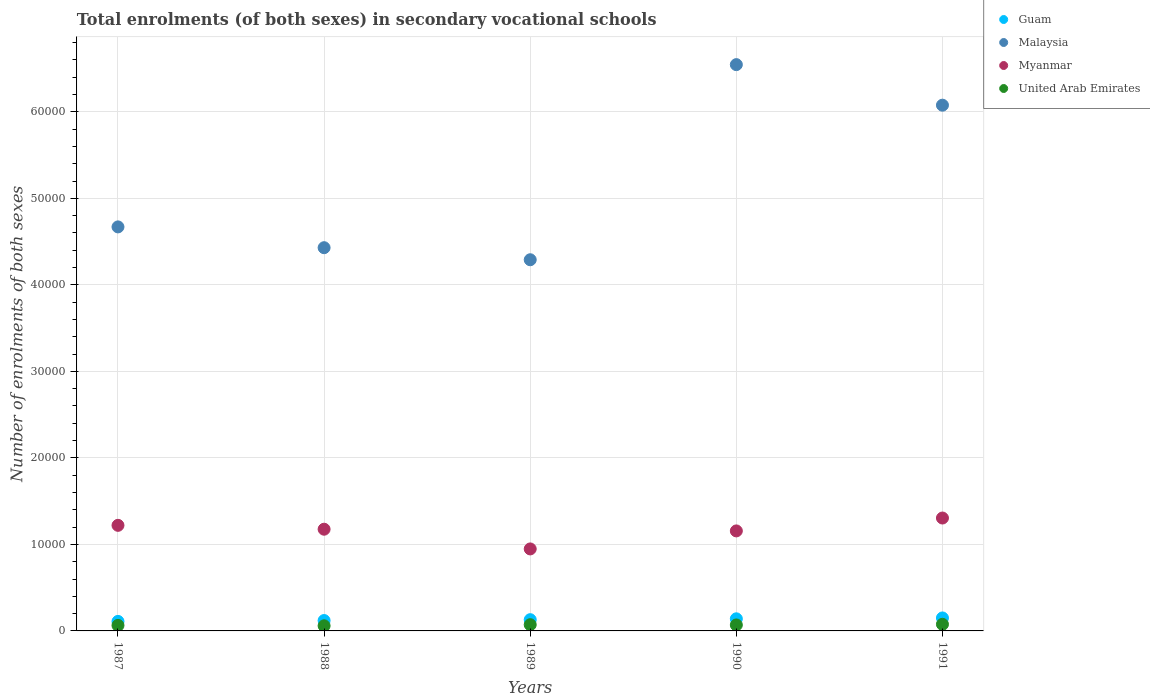How many different coloured dotlines are there?
Offer a terse response. 4. Is the number of dotlines equal to the number of legend labels?
Offer a terse response. Yes. What is the number of enrolments in secondary schools in United Arab Emirates in 1988?
Your answer should be compact. 591. Across all years, what is the maximum number of enrolments in secondary schools in Myanmar?
Keep it short and to the point. 1.30e+04. Across all years, what is the minimum number of enrolments in secondary schools in Malaysia?
Your answer should be very brief. 4.29e+04. In which year was the number of enrolments in secondary schools in Guam maximum?
Give a very brief answer. 1991. In which year was the number of enrolments in secondary schools in Myanmar minimum?
Make the answer very short. 1989. What is the total number of enrolments in secondary schools in Malaysia in the graph?
Provide a short and direct response. 2.60e+05. What is the difference between the number of enrolments in secondary schools in United Arab Emirates in 1987 and that in 1988?
Make the answer very short. 47. What is the difference between the number of enrolments in secondary schools in Malaysia in 1988 and the number of enrolments in secondary schools in Guam in 1987?
Offer a very short reply. 4.32e+04. What is the average number of enrolments in secondary schools in Myanmar per year?
Your response must be concise. 1.16e+04. In the year 1990, what is the difference between the number of enrolments in secondary schools in United Arab Emirates and number of enrolments in secondary schools in Myanmar?
Provide a short and direct response. -1.09e+04. In how many years, is the number of enrolments in secondary schools in United Arab Emirates greater than 38000?
Your answer should be compact. 0. What is the ratio of the number of enrolments in secondary schools in Guam in 1988 to that in 1990?
Your answer should be compact. 0.86. Is the number of enrolments in secondary schools in Guam in 1987 less than that in 1988?
Offer a very short reply. Yes. Is the difference between the number of enrolments in secondary schools in United Arab Emirates in 1987 and 1991 greater than the difference between the number of enrolments in secondary schools in Myanmar in 1987 and 1991?
Provide a succinct answer. Yes. What is the difference between the highest and the second highest number of enrolments in secondary schools in Malaysia?
Ensure brevity in your answer.  4687. What is the difference between the highest and the lowest number of enrolments in secondary schools in United Arab Emirates?
Your answer should be compact. 175. In how many years, is the number of enrolments in secondary schools in Malaysia greater than the average number of enrolments in secondary schools in Malaysia taken over all years?
Your answer should be very brief. 2. Is the sum of the number of enrolments in secondary schools in Myanmar in 1988 and 1989 greater than the maximum number of enrolments in secondary schools in Malaysia across all years?
Offer a very short reply. No. Is it the case that in every year, the sum of the number of enrolments in secondary schools in Malaysia and number of enrolments in secondary schools in Myanmar  is greater than the sum of number of enrolments in secondary schools in United Arab Emirates and number of enrolments in secondary schools in Guam?
Make the answer very short. Yes. Is the number of enrolments in secondary schools in Malaysia strictly greater than the number of enrolments in secondary schools in United Arab Emirates over the years?
Your answer should be compact. Yes. Is the number of enrolments in secondary schools in Guam strictly less than the number of enrolments in secondary schools in United Arab Emirates over the years?
Offer a very short reply. No. How many dotlines are there?
Give a very brief answer. 4. What is the difference between two consecutive major ticks on the Y-axis?
Keep it short and to the point. 10000. Are the values on the major ticks of Y-axis written in scientific E-notation?
Offer a terse response. No. Does the graph contain any zero values?
Give a very brief answer. No. Does the graph contain grids?
Keep it short and to the point. Yes. How are the legend labels stacked?
Keep it short and to the point. Vertical. What is the title of the graph?
Provide a short and direct response. Total enrolments (of both sexes) in secondary vocational schools. What is the label or title of the Y-axis?
Your response must be concise. Number of enrolments of both sexes. What is the Number of enrolments of both sexes of Guam in 1987?
Give a very brief answer. 1100. What is the Number of enrolments of both sexes in Malaysia in 1987?
Your answer should be very brief. 4.67e+04. What is the Number of enrolments of both sexes of Myanmar in 1987?
Provide a short and direct response. 1.22e+04. What is the Number of enrolments of both sexes of United Arab Emirates in 1987?
Provide a short and direct response. 638. What is the Number of enrolments of both sexes of Guam in 1988?
Ensure brevity in your answer.  1200. What is the Number of enrolments of both sexes of Malaysia in 1988?
Your answer should be compact. 4.43e+04. What is the Number of enrolments of both sexes of Myanmar in 1988?
Make the answer very short. 1.18e+04. What is the Number of enrolments of both sexes in United Arab Emirates in 1988?
Your response must be concise. 591. What is the Number of enrolments of both sexes in Guam in 1989?
Your answer should be compact. 1300. What is the Number of enrolments of both sexes in Malaysia in 1989?
Provide a succinct answer. 4.29e+04. What is the Number of enrolments of both sexes of Myanmar in 1989?
Ensure brevity in your answer.  9478. What is the Number of enrolments of both sexes in United Arab Emirates in 1989?
Offer a terse response. 720. What is the Number of enrolments of both sexes in Guam in 1990?
Keep it short and to the point. 1400. What is the Number of enrolments of both sexes in Malaysia in 1990?
Provide a succinct answer. 6.55e+04. What is the Number of enrolments of both sexes of Myanmar in 1990?
Keep it short and to the point. 1.16e+04. What is the Number of enrolments of both sexes of United Arab Emirates in 1990?
Provide a succinct answer. 690. What is the Number of enrolments of both sexes in Guam in 1991?
Provide a short and direct response. 1500. What is the Number of enrolments of both sexes of Malaysia in 1991?
Offer a terse response. 6.08e+04. What is the Number of enrolments of both sexes in Myanmar in 1991?
Offer a very short reply. 1.30e+04. What is the Number of enrolments of both sexes in United Arab Emirates in 1991?
Your response must be concise. 766. Across all years, what is the maximum Number of enrolments of both sexes of Guam?
Your answer should be very brief. 1500. Across all years, what is the maximum Number of enrolments of both sexes in Malaysia?
Make the answer very short. 6.55e+04. Across all years, what is the maximum Number of enrolments of both sexes in Myanmar?
Provide a short and direct response. 1.30e+04. Across all years, what is the maximum Number of enrolments of both sexes of United Arab Emirates?
Your answer should be very brief. 766. Across all years, what is the minimum Number of enrolments of both sexes in Guam?
Make the answer very short. 1100. Across all years, what is the minimum Number of enrolments of both sexes of Malaysia?
Give a very brief answer. 4.29e+04. Across all years, what is the minimum Number of enrolments of both sexes of Myanmar?
Make the answer very short. 9478. Across all years, what is the minimum Number of enrolments of both sexes in United Arab Emirates?
Give a very brief answer. 591. What is the total Number of enrolments of both sexes in Guam in the graph?
Keep it short and to the point. 6500. What is the total Number of enrolments of both sexes in Malaysia in the graph?
Provide a succinct answer. 2.60e+05. What is the total Number of enrolments of both sexes in Myanmar in the graph?
Provide a succinct answer. 5.81e+04. What is the total Number of enrolments of both sexes of United Arab Emirates in the graph?
Your answer should be very brief. 3405. What is the difference between the Number of enrolments of both sexes in Guam in 1987 and that in 1988?
Offer a very short reply. -100. What is the difference between the Number of enrolments of both sexes of Malaysia in 1987 and that in 1988?
Your response must be concise. 2404. What is the difference between the Number of enrolments of both sexes of Myanmar in 1987 and that in 1988?
Your answer should be very brief. 448. What is the difference between the Number of enrolments of both sexes of United Arab Emirates in 1987 and that in 1988?
Give a very brief answer. 47. What is the difference between the Number of enrolments of both sexes of Guam in 1987 and that in 1989?
Offer a very short reply. -200. What is the difference between the Number of enrolments of both sexes in Malaysia in 1987 and that in 1989?
Provide a succinct answer. 3797. What is the difference between the Number of enrolments of both sexes in Myanmar in 1987 and that in 1989?
Your answer should be very brief. 2727. What is the difference between the Number of enrolments of both sexes of United Arab Emirates in 1987 and that in 1989?
Ensure brevity in your answer.  -82. What is the difference between the Number of enrolments of both sexes of Guam in 1987 and that in 1990?
Make the answer very short. -300. What is the difference between the Number of enrolments of both sexes of Malaysia in 1987 and that in 1990?
Your answer should be compact. -1.88e+04. What is the difference between the Number of enrolments of both sexes in Myanmar in 1987 and that in 1990?
Give a very brief answer. 644. What is the difference between the Number of enrolments of both sexes of United Arab Emirates in 1987 and that in 1990?
Provide a succinct answer. -52. What is the difference between the Number of enrolments of both sexes in Guam in 1987 and that in 1991?
Keep it short and to the point. -400. What is the difference between the Number of enrolments of both sexes of Malaysia in 1987 and that in 1991?
Provide a short and direct response. -1.41e+04. What is the difference between the Number of enrolments of both sexes in Myanmar in 1987 and that in 1991?
Give a very brief answer. -845. What is the difference between the Number of enrolments of both sexes of United Arab Emirates in 1987 and that in 1991?
Offer a terse response. -128. What is the difference between the Number of enrolments of both sexes in Guam in 1988 and that in 1989?
Ensure brevity in your answer.  -100. What is the difference between the Number of enrolments of both sexes of Malaysia in 1988 and that in 1989?
Offer a very short reply. 1393. What is the difference between the Number of enrolments of both sexes in Myanmar in 1988 and that in 1989?
Provide a short and direct response. 2279. What is the difference between the Number of enrolments of both sexes in United Arab Emirates in 1988 and that in 1989?
Ensure brevity in your answer.  -129. What is the difference between the Number of enrolments of both sexes in Guam in 1988 and that in 1990?
Keep it short and to the point. -200. What is the difference between the Number of enrolments of both sexes in Malaysia in 1988 and that in 1990?
Your answer should be compact. -2.12e+04. What is the difference between the Number of enrolments of both sexes in Myanmar in 1988 and that in 1990?
Keep it short and to the point. 196. What is the difference between the Number of enrolments of both sexes in United Arab Emirates in 1988 and that in 1990?
Give a very brief answer. -99. What is the difference between the Number of enrolments of both sexes of Guam in 1988 and that in 1991?
Make the answer very short. -300. What is the difference between the Number of enrolments of both sexes of Malaysia in 1988 and that in 1991?
Offer a very short reply. -1.65e+04. What is the difference between the Number of enrolments of both sexes in Myanmar in 1988 and that in 1991?
Your answer should be very brief. -1293. What is the difference between the Number of enrolments of both sexes in United Arab Emirates in 1988 and that in 1991?
Make the answer very short. -175. What is the difference between the Number of enrolments of both sexes of Guam in 1989 and that in 1990?
Ensure brevity in your answer.  -100. What is the difference between the Number of enrolments of both sexes in Malaysia in 1989 and that in 1990?
Make the answer very short. -2.26e+04. What is the difference between the Number of enrolments of both sexes of Myanmar in 1989 and that in 1990?
Your response must be concise. -2083. What is the difference between the Number of enrolments of both sexes of United Arab Emirates in 1989 and that in 1990?
Make the answer very short. 30. What is the difference between the Number of enrolments of both sexes in Guam in 1989 and that in 1991?
Ensure brevity in your answer.  -200. What is the difference between the Number of enrolments of both sexes of Malaysia in 1989 and that in 1991?
Provide a succinct answer. -1.79e+04. What is the difference between the Number of enrolments of both sexes in Myanmar in 1989 and that in 1991?
Offer a terse response. -3572. What is the difference between the Number of enrolments of both sexes of United Arab Emirates in 1989 and that in 1991?
Provide a short and direct response. -46. What is the difference between the Number of enrolments of both sexes in Guam in 1990 and that in 1991?
Offer a very short reply. -100. What is the difference between the Number of enrolments of both sexes of Malaysia in 1990 and that in 1991?
Offer a very short reply. 4687. What is the difference between the Number of enrolments of both sexes of Myanmar in 1990 and that in 1991?
Give a very brief answer. -1489. What is the difference between the Number of enrolments of both sexes in United Arab Emirates in 1990 and that in 1991?
Provide a short and direct response. -76. What is the difference between the Number of enrolments of both sexes in Guam in 1987 and the Number of enrolments of both sexes in Malaysia in 1988?
Keep it short and to the point. -4.32e+04. What is the difference between the Number of enrolments of both sexes of Guam in 1987 and the Number of enrolments of both sexes of Myanmar in 1988?
Keep it short and to the point. -1.07e+04. What is the difference between the Number of enrolments of both sexes in Guam in 1987 and the Number of enrolments of both sexes in United Arab Emirates in 1988?
Your answer should be compact. 509. What is the difference between the Number of enrolments of both sexes of Malaysia in 1987 and the Number of enrolments of both sexes of Myanmar in 1988?
Your response must be concise. 3.49e+04. What is the difference between the Number of enrolments of both sexes in Malaysia in 1987 and the Number of enrolments of both sexes in United Arab Emirates in 1988?
Provide a short and direct response. 4.61e+04. What is the difference between the Number of enrolments of both sexes in Myanmar in 1987 and the Number of enrolments of both sexes in United Arab Emirates in 1988?
Your answer should be compact. 1.16e+04. What is the difference between the Number of enrolments of both sexes of Guam in 1987 and the Number of enrolments of both sexes of Malaysia in 1989?
Offer a terse response. -4.18e+04. What is the difference between the Number of enrolments of both sexes in Guam in 1987 and the Number of enrolments of both sexes in Myanmar in 1989?
Provide a short and direct response. -8378. What is the difference between the Number of enrolments of both sexes of Guam in 1987 and the Number of enrolments of both sexes of United Arab Emirates in 1989?
Ensure brevity in your answer.  380. What is the difference between the Number of enrolments of both sexes of Malaysia in 1987 and the Number of enrolments of both sexes of Myanmar in 1989?
Your response must be concise. 3.72e+04. What is the difference between the Number of enrolments of both sexes in Malaysia in 1987 and the Number of enrolments of both sexes in United Arab Emirates in 1989?
Make the answer very short. 4.60e+04. What is the difference between the Number of enrolments of both sexes of Myanmar in 1987 and the Number of enrolments of both sexes of United Arab Emirates in 1989?
Offer a terse response. 1.15e+04. What is the difference between the Number of enrolments of both sexes in Guam in 1987 and the Number of enrolments of both sexes in Malaysia in 1990?
Offer a very short reply. -6.44e+04. What is the difference between the Number of enrolments of both sexes in Guam in 1987 and the Number of enrolments of both sexes in Myanmar in 1990?
Keep it short and to the point. -1.05e+04. What is the difference between the Number of enrolments of both sexes in Guam in 1987 and the Number of enrolments of both sexes in United Arab Emirates in 1990?
Your response must be concise. 410. What is the difference between the Number of enrolments of both sexes in Malaysia in 1987 and the Number of enrolments of both sexes in Myanmar in 1990?
Provide a short and direct response. 3.51e+04. What is the difference between the Number of enrolments of both sexes in Malaysia in 1987 and the Number of enrolments of both sexes in United Arab Emirates in 1990?
Provide a succinct answer. 4.60e+04. What is the difference between the Number of enrolments of both sexes of Myanmar in 1987 and the Number of enrolments of both sexes of United Arab Emirates in 1990?
Offer a terse response. 1.15e+04. What is the difference between the Number of enrolments of both sexes of Guam in 1987 and the Number of enrolments of both sexes of Malaysia in 1991?
Your answer should be compact. -5.97e+04. What is the difference between the Number of enrolments of both sexes of Guam in 1987 and the Number of enrolments of both sexes of Myanmar in 1991?
Ensure brevity in your answer.  -1.20e+04. What is the difference between the Number of enrolments of both sexes of Guam in 1987 and the Number of enrolments of both sexes of United Arab Emirates in 1991?
Your response must be concise. 334. What is the difference between the Number of enrolments of both sexes in Malaysia in 1987 and the Number of enrolments of both sexes in Myanmar in 1991?
Give a very brief answer. 3.37e+04. What is the difference between the Number of enrolments of both sexes of Malaysia in 1987 and the Number of enrolments of both sexes of United Arab Emirates in 1991?
Your response must be concise. 4.59e+04. What is the difference between the Number of enrolments of both sexes in Myanmar in 1987 and the Number of enrolments of both sexes in United Arab Emirates in 1991?
Your answer should be compact. 1.14e+04. What is the difference between the Number of enrolments of both sexes of Guam in 1988 and the Number of enrolments of both sexes of Malaysia in 1989?
Keep it short and to the point. -4.17e+04. What is the difference between the Number of enrolments of both sexes in Guam in 1988 and the Number of enrolments of both sexes in Myanmar in 1989?
Offer a terse response. -8278. What is the difference between the Number of enrolments of both sexes in Guam in 1988 and the Number of enrolments of both sexes in United Arab Emirates in 1989?
Give a very brief answer. 480. What is the difference between the Number of enrolments of both sexes of Malaysia in 1988 and the Number of enrolments of both sexes of Myanmar in 1989?
Keep it short and to the point. 3.48e+04. What is the difference between the Number of enrolments of both sexes of Malaysia in 1988 and the Number of enrolments of both sexes of United Arab Emirates in 1989?
Give a very brief answer. 4.36e+04. What is the difference between the Number of enrolments of both sexes in Myanmar in 1988 and the Number of enrolments of both sexes in United Arab Emirates in 1989?
Make the answer very short. 1.10e+04. What is the difference between the Number of enrolments of both sexes in Guam in 1988 and the Number of enrolments of both sexes in Malaysia in 1990?
Your answer should be compact. -6.43e+04. What is the difference between the Number of enrolments of both sexes in Guam in 1988 and the Number of enrolments of both sexes in Myanmar in 1990?
Offer a terse response. -1.04e+04. What is the difference between the Number of enrolments of both sexes of Guam in 1988 and the Number of enrolments of both sexes of United Arab Emirates in 1990?
Your answer should be compact. 510. What is the difference between the Number of enrolments of both sexes of Malaysia in 1988 and the Number of enrolments of both sexes of Myanmar in 1990?
Your response must be concise. 3.27e+04. What is the difference between the Number of enrolments of both sexes of Malaysia in 1988 and the Number of enrolments of both sexes of United Arab Emirates in 1990?
Make the answer very short. 4.36e+04. What is the difference between the Number of enrolments of both sexes in Myanmar in 1988 and the Number of enrolments of both sexes in United Arab Emirates in 1990?
Your answer should be very brief. 1.11e+04. What is the difference between the Number of enrolments of both sexes in Guam in 1988 and the Number of enrolments of both sexes in Malaysia in 1991?
Your response must be concise. -5.96e+04. What is the difference between the Number of enrolments of both sexes in Guam in 1988 and the Number of enrolments of both sexes in Myanmar in 1991?
Your answer should be compact. -1.18e+04. What is the difference between the Number of enrolments of both sexes in Guam in 1988 and the Number of enrolments of both sexes in United Arab Emirates in 1991?
Provide a short and direct response. 434. What is the difference between the Number of enrolments of both sexes in Malaysia in 1988 and the Number of enrolments of both sexes in Myanmar in 1991?
Give a very brief answer. 3.12e+04. What is the difference between the Number of enrolments of both sexes of Malaysia in 1988 and the Number of enrolments of both sexes of United Arab Emirates in 1991?
Keep it short and to the point. 4.35e+04. What is the difference between the Number of enrolments of both sexes of Myanmar in 1988 and the Number of enrolments of both sexes of United Arab Emirates in 1991?
Your answer should be compact. 1.10e+04. What is the difference between the Number of enrolments of both sexes of Guam in 1989 and the Number of enrolments of both sexes of Malaysia in 1990?
Make the answer very short. -6.42e+04. What is the difference between the Number of enrolments of both sexes in Guam in 1989 and the Number of enrolments of both sexes in Myanmar in 1990?
Your answer should be very brief. -1.03e+04. What is the difference between the Number of enrolments of both sexes of Guam in 1989 and the Number of enrolments of both sexes of United Arab Emirates in 1990?
Ensure brevity in your answer.  610. What is the difference between the Number of enrolments of both sexes in Malaysia in 1989 and the Number of enrolments of both sexes in Myanmar in 1990?
Ensure brevity in your answer.  3.13e+04. What is the difference between the Number of enrolments of both sexes of Malaysia in 1989 and the Number of enrolments of both sexes of United Arab Emirates in 1990?
Make the answer very short. 4.22e+04. What is the difference between the Number of enrolments of both sexes in Myanmar in 1989 and the Number of enrolments of both sexes in United Arab Emirates in 1990?
Your response must be concise. 8788. What is the difference between the Number of enrolments of both sexes of Guam in 1989 and the Number of enrolments of both sexes of Malaysia in 1991?
Ensure brevity in your answer.  -5.95e+04. What is the difference between the Number of enrolments of both sexes in Guam in 1989 and the Number of enrolments of both sexes in Myanmar in 1991?
Keep it short and to the point. -1.18e+04. What is the difference between the Number of enrolments of both sexes of Guam in 1989 and the Number of enrolments of both sexes of United Arab Emirates in 1991?
Provide a succinct answer. 534. What is the difference between the Number of enrolments of both sexes in Malaysia in 1989 and the Number of enrolments of both sexes in Myanmar in 1991?
Keep it short and to the point. 2.99e+04. What is the difference between the Number of enrolments of both sexes in Malaysia in 1989 and the Number of enrolments of both sexes in United Arab Emirates in 1991?
Ensure brevity in your answer.  4.21e+04. What is the difference between the Number of enrolments of both sexes of Myanmar in 1989 and the Number of enrolments of both sexes of United Arab Emirates in 1991?
Ensure brevity in your answer.  8712. What is the difference between the Number of enrolments of both sexes of Guam in 1990 and the Number of enrolments of both sexes of Malaysia in 1991?
Make the answer very short. -5.94e+04. What is the difference between the Number of enrolments of both sexes in Guam in 1990 and the Number of enrolments of both sexes in Myanmar in 1991?
Your response must be concise. -1.16e+04. What is the difference between the Number of enrolments of both sexes in Guam in 1990 and the Number of enrolments of both sexes in United Arab Emirates in 1991?
Your answer should be compact. 634. What is the difference between the Number of enrolments of both sexes in Malaysia in 1990 and the Number of enrolments of both sexes in Myanmar in 1991?
Ensure brevity in your answer.  5.24e+04. What is the difference between the Number of enrolments of both sexes of Malaysia in 1990 and the Number of enrolments of both sexes of United Arab Emirates in 1991?
Ensure brevity in your answer.  6.47e+04. What is the difference between the Number of enrolments of both sexes in Myanmar in 1990 and the Number of enrolments of both sexes in United Arab Emirates in 1991?
Offer a terse response. 1.08e+04. What is the average Number of enrolments of both sexes in Guam per year?
Provide a succinct answer. 1300. What is the average Number of enrolments of both sexes of Malaysia per year?
Give a very brief answer. 5.20e+04. What is the average Number of enrolments of both sexes of Myanmar per year?
Provide a short and direct response. 1.16e+04. What is the average Number of enrolments of both sexes of United Arab Emirates per year?
Your response must be concise. 681. In the year 1987, what is the difference between the Number of enrolments of both sexes of Guam and Number of enrolments of both sexes of Malaysia?
Offer a very short reply. -4.56e+04. In the year 1987, what is the difference between the Number of enrolments of both sexes of Guam and Number of enrolments of both sexes of Myanmar?
Provide a succinct answer. -1.11e+04. In the year 1987, what is the difference between the Number of enrolments of both sexes in Guam and Number of enrolments of both sexes in United Arab Emirates?
Provide a succinct answer. 462. In the year 1987, what is the difference between the Number of enrolments of both sexes of Malaysia and Number of enrolments of both sexes of Myanmar?
Offer a very short reply. 3.45e+04. In the year 1987, what is the difference between the Number of enrolments of both sexes of Malaysia and Number of enrolments of both sexes of United Arab Emirates?
Offer a very short reply. 4.61e+04. In the year 1987, what is the difference between the Number of enrolments of both sexes of Myanmar and Number of enrolments of both sexes of United Arab Emirates?
Give a very brief answer. 1.16e+04. In the year 1988, what is the difference between the Number of enrolments of both sexes of Guam and Number of enrolments of both sexes of Malaysia?
Your response must be concise. -4.31e+04. In the year 1988, what is the difference between the Number of enrolments of both sexes of Guam and Number of enrolments of both sexes of Myanmar?
Your response must be concise. -1.06e+04. In the year 1988, what is the difference between the Number of enrolments of both sexes of Guam and Number of enrolments of both sexes of United Arab Emirates?
Provide a short and direct response. 609. In the year 1988, what is the difference between the Number of enrolments of both sexes in Malaysia and Number of enrolments of both sexes in Myanmar?
Keep it short and to the point. 3.25e+04. In the year 1988, what is the difference between the Number of enrolments of both sexes of Malaysia and Number of enrolments of both sexes of United Arab Emirates?
Your response must be concise. 4.37e+04. In the year 1988, what is the difference between the Number of enrolments of both sexes in Myanmar and Number of enrolments of both sexes in United Arab Emirates?
Your answer should be very brief. 1.12e+04. In the year 1989, what is the difference between the Number of enrolments of both sexes in Guam and Number of enrolments of both sexes in Malaysia?
Your answer should be very brief. -4.16e+04. In the year 1989, what is the difference between the Number of enrolments of both sexes of Guam and Number of enrolments of both sexes of Myanmar?
Provide a short and direct response. -8178. In the year 1989, what is the difference between the Number of enrolments of both sexes of Guam and Number of enrolments of both sexes of United Arab Emirates?
Your answer should be very brief. 580. In the year 1989, what is the difference between the Number of enrolments of both sexes in Malaysia and Number of enrolments of both sexes in Myanmar?
Offer a terse response. 3.34e+04. In the year 1989, what is the difference between the Number of enrolments of both sexes of Malaysia and Number of enrolments of both sexes of United Arab Emirates?
Give a very brief answer. 4.22e+04. In the year 1989, what is the difference between the Number of enrolments of both sexes in Myanmar and Number of enrolments of both sexes in United Arab Emirates?
Your response must be concise. 8758. In the year 1990, what is the difference between the Number of enrolments of both sexes of Guam and Number of enrolments of both sexes of Malaysia?
Your answer should be very brief. -6.41e+04. In the year 1990, what is the difference between the Number of enrolments of both sexes of Guam and Number of enrolments of both sexes of Myanmar?
Offer a very short reply. -1.02e+04. In the year 1990, what is the difference between the Number of enrolments of both sexes of Guam and Number of enrolments of both sexes of United Arab Emirates?
Your answer should be compact. 710. In the year 1990, what is the difference between the Number of enrolments of both sexes of Malaysia and Number of enrolments of both sexes of Myanmar?
Provide a succinct answer. 5.39e+04. In the year 1990, what is the difference between the Number of enrolments of both sexes in Malaysia and Number of enrolments of both sexes in United Arab Emirates?
Ensure brevity in your answer.  6.48e+04. In the year 1990, what is the difference between the Number of enrolments of both sexes of Myanmar and Number of enrolments of both sexes of United Arab Emirates?
Your response must be concise. 1.09e+04. In the year 1991, what is the difference between the Number of enrolments of both sexes in Guam and Number of enrolments of both sexes in Malaysia?
Offer a very short reply. -5.93e+04. In the year 1991, what is the difference between the Number of enrolments of both sexes in Guam and Number of enrolments of both sexes in Myanmar?
Make the answer very short. -1.16e+04. In the year 1991, what is the difference between the Number of enrolments of both sexes in Guam and Number of enrolments of both sexes in United Arab Emirates?
Ensure brevity in your answer.  734. In the year 1991, what is the difference between the Number of enrolments of both sexes of Malaysia and Number of enrolments of both sexes of Myanmar?
Ensure brevity in your answer.  4.77e+04. In the year 1991, what is the difference between the Number of enrolments of both sexes in Malaysia and Number of enrolments of both sexes in United Arab Emirates?
Your answer should be compact. 6.00e+04. In the year 1991, what is the difference between the Number of enrolments of both sexes in Myanmar and Number of enrolments of both sexes in United Arab Emirates?
Offer a terse response. 1.23e+04. What is the ratio of the Number of enrolments of both sexes in Malaysia in 1987 to that in 1988?
Your answer should be very brief. 1.05. What is the ratio of the Number of enrolments of both sexes in Myanmar in 1987 to that in 1988?
Keep it short and to the point. 1.04. What is the ratio of the Number of enrolments of both sexes of United Arab Emirates in 1987 to that in 1988?
Keep it short and to the point. 1.08. What is the ratio of the Number of enrolments of both sexes of Guam in 1987 to that in 1989?
Ensure brevity in your answer.  0.85. What is the ratio of the Number of enrolments of both sexes of Malaysia in 1987 to that in 1989?
Give a very brief answer. 1.09. What is the ratio of the Number of enrolments of both sexes of Myanmar in 1987 to that in 1989?
Your response must be concise. 1.29. What is the ratio of the Number of enrolments of both sexes in United Arab Emirates in 1987 to that in 1989?
Give a very brief answer. 0.89. What is the ratio of the Number of enrolments of both sexes in Guam in 1987 to that in 1990?
Provide a succinct answer. 0.79. What is the ratio of the Number of enrolments of both sexes in Malaysia in 1987 to that in 1990?
Give a very brief answer. 0.71. What is the ratio of the Number of enrolments of both sexes in Myanmar in 1987 to that in 1990?
Provide a short and direct response. 1.06. What is the ratio of the Number of enrolments of both sexes in United Arab Emirates in 1987 to that in 1990?
Provide a succinct answer. 0.92. What is the ratio of the Number of enrolments of both sexes in Guam in 1987 to that in 1991?
Your response must be concise. 0.73. What is the ratio of the Number of enrolments of both sexes in Malaysia in 1987 to that in 1991?
Your response must be concise. 0.77. What is the ratio of the Number of enrolments of both sexes in Myanmar in 1987 to that in 1991?
Your answer should be very brief. 0.94. What is the ratio of the Number of enrolments of both sexes in United Arab Emirates in 1987 to that in 1991?
Your response must be concise. 0.83. What is the ratio of the Number of enrolments of both sexes of Guam in 1988 to that in 1989?
Provide a short and direct response. 0.92. What is the ratio of the Number of enrolments of both sexes in Malaysia in 1988 to that in 1989?
Offer a terse response. 1.03. What is the ratio of the Number of enrolments of both sexes of Myanmar in 1988 to that in 1989?
Provide a short and direct response. 1.24. What is the ratio of the Number of enrolments of both sexes in United Arab Emirates in 1988 to that in 1989?
Give a very brief answer. 0.82. What is the ratio of the Number of enrolments of both sexes in Guam in 1988 to that in 1990?
Provide a short and direct response. 0.86. What is the ratio of the Number of enrolments of both sexes of Malaysia in 1988 to that in 1990?
Provide a succinct answer. 0.68. What is the ratio of the Number of enrolments of both sexes of Myanmar in 1988 to that in 1990?
Your response must be concise. 1.02. What is the ratio of the Number of enrolments of both sexes of United Arab Emirates in 1988 to that in 1990?
Ensure brevity in your answer.  0.86. What is the ratio of the Number of enrolments of both sexes in Guam in 1988 to that in 1991?
Your answer should be very brief. 0.8. What is the ratio of the Number of enrolments of both sexes of Malaysia in 1988 to that in 1991?
Offer a terse response. 0.73. What is the ratio of the Number of enrolments of both sexes of Myanmar in 1988 to that in 1991?
Provide a succinct answer. 0.9. What is the ratio of the Number of enrolments of both sexes in United Arab Emirates in 1988 to that in 1991?
Your answer should be compact. 0.77. What is the ratio of the Number of enrolments of both sexes of Guam in 1989 to that in 1990?
Keep it short and to the point. 0.93. What is the ratio of the Number of enrolments of both sexes of Malaysia in 1989 to that in 1990?
Provide a short and direct response. 0.66. What is the ratio of the Number of enrolments of both sexes in Myanmar in 1989 to that in 1990?
Offer a terse response. 0.82. What is the ratio of the Number of enrolments of both sexes in United Arab Emirates in 1989 to that in 1990?
Your response must be concise. 1.04. What is the ratio of the Number of enrolments of both sexes in Guam in 1989 to that in 1991?
Make the answer very short. 0.87. What is the ratio of the Number of enrolments of both sexes in Malaysia in 1989 to that in 1991?
Make the answer very short. 0.71. What is the ratio of the Number of enrolments of both sexes of Myanmar in 1989 to that in 1991?
Provide a succinct answer. 0.73. What is the ratio of the Number of enrolments of both sexes of United Arab Emirates in 1989 to that in 1991?
Provide a succinct answer. 0.94. What is the ratio of the Number of enrolments of both sexes of Guam in 1990 to that in 1991?
Keep it short and to the point. 0.93. What is the ratio of the Number of enrolments of both sexes of Malaysia in 1990 to that in 1991?
Provide a short and direct response. 1.08. What is the ratio of the Number of enrolments of both sexes of Myanmar in 1990 to that in 1991?
Provide a succinct answer. 0.89. What is the ratio of the Number of enrolments of both sexes of United Arab Emirates in 1990 to that in 1991?
Provide a succinct answer. 0.9. What is the difference between the highest and the second highest Number of enrolments of both sexes of Malaysia?
Provide a short and direct response. 4687. What is the difference between the highest and the second highest Number of enrolments of both sexes of Myanmar?
Make the answer very short. 845. What is the difference between the highest and the second highest Number of enrolments of both sexes of United Arab Emirates?
Your answer should be compact. 46. What is the difference between the highest and the lowest Number of enrolments of both sexes of Malaysia?
Keep it short and to the point. 2.26e+04. What is the difference between the highest and the lowest Number of enrolments of both sexes in Myanmar?
Ensure brevity in your answer.  3572. What is the difference between the highest and the lowest Number of enrolments of both sexes in United Arab Emirates?
Your answer should be compact. 175. 